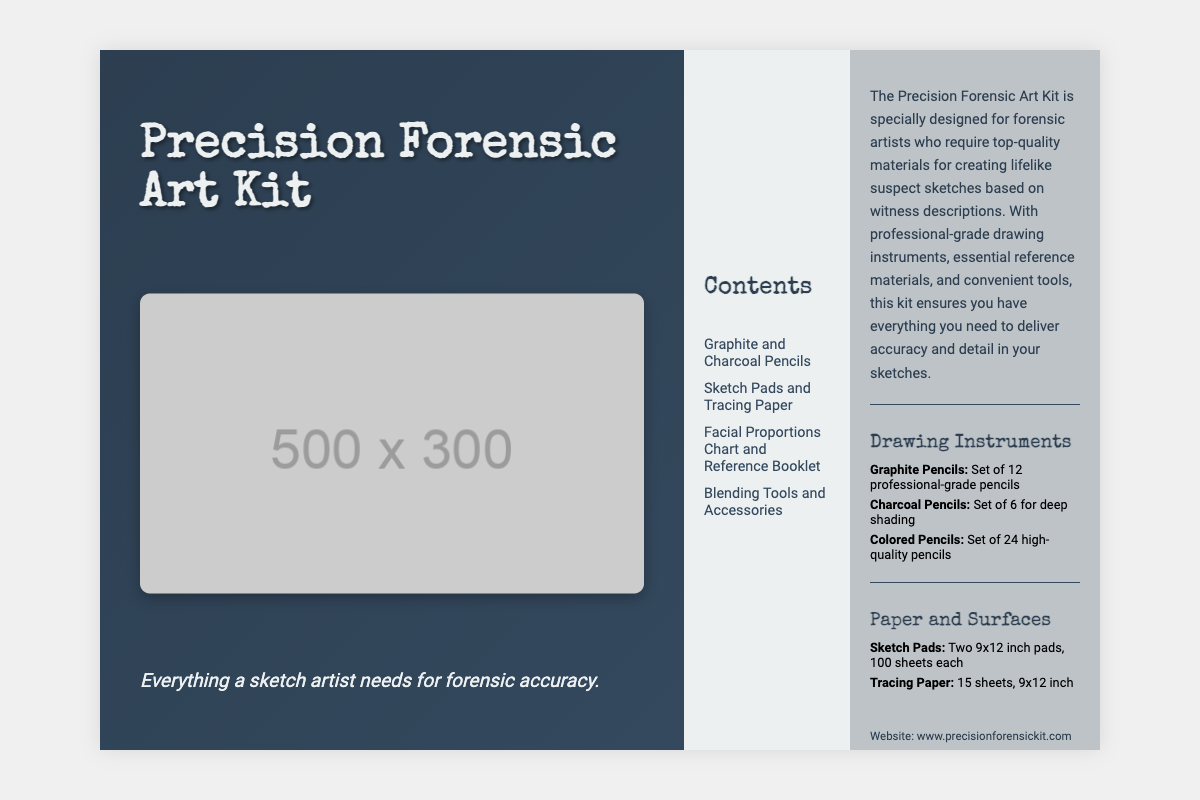What is the title of the kit? The title is prominently displayed on the front section of the document, indicating the product name.
Answer: Precision Forensic Art Kit How many graphite pencils are included? The number of graphite pencils is specified in the drawing instruments section of the document.
Answer: Set of 12 What type of paper is included in the kit? The paper types are listed under the "Paper and Surfaces" category in the document.
Answer: Sketch Pads and Tracing Paper What is the purpose of the kit? The purpose is described in the back section, highlighting the target audience and use.
Answer: Forensic artists How many sheets are in each sketch pad? The quantity of sheets per sketch pad is mentioned in the "Paper and Surfaces" section.
Answer: 100 sheets each What is a unique feature of the drawing instruments? A specific feature is highlighted in the list of drawing instruments regarding quality.
Answer: Professional-grade What type of accessories are included in the kit? The types of accessories are listed in the contents section of the document.
Answer: Blending Tools and Accessories What is the customer service phone number? The customer service number is provided in the contact information section.
Answer: 1-800-FORENSIC What is the website for the Precision Forensic Art Kit? The website is included in the contact information for customers seeking more details.
Answer: www.precisionforensickit.com 